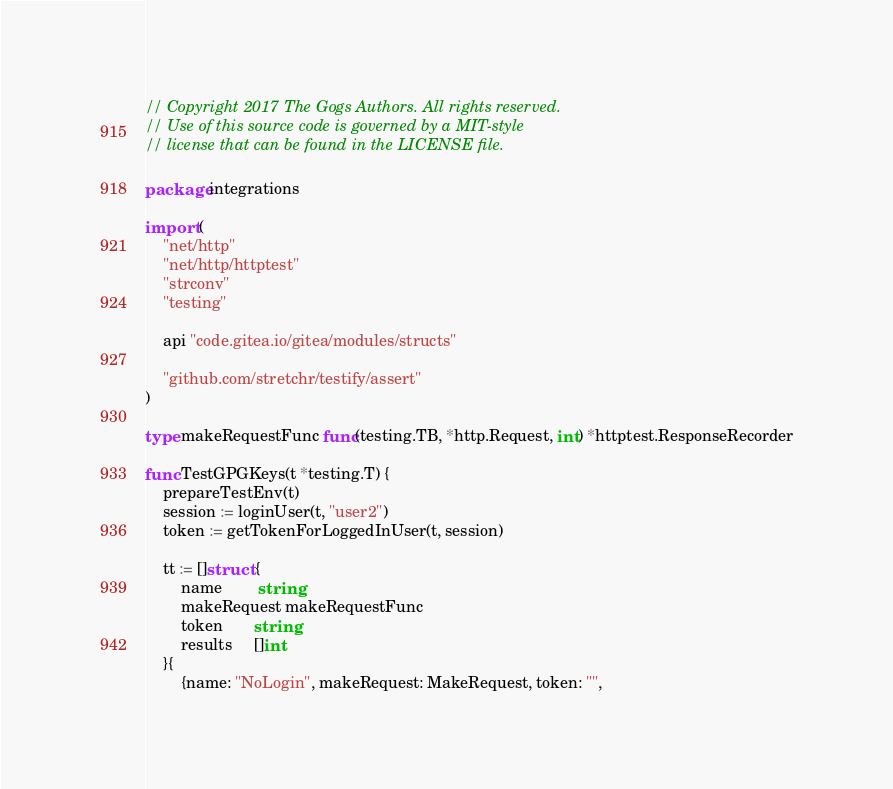<code> <loc_0><loc_0><loc_500><loc_500><_Go_>// Copyright 2017 The Gogs Authors. All rights reserved.
// Use of this source code is governed by a MIT-style
// license that can be found in the LICENSE file.

package integrations

import (
	"net/http"
	"net/http/httptest"
	"strconv"
	"testing"

	api "code.gitea.io/gitea/modules/structs"

	"github.com/stretchr/testify/assert"
)

type makeRequestFunc func(testing.TB, *http.Request, int) *httptest.ResponseRecorder

func TestGPGKeys(t *testing.T) {
	prepareTestEnv(t)
	session := loginUser(t, "user2")
	token := getTokenForLoggedInUser(t, session)

	tt := []struct {
		name        string
		makeRequest makeRequestFunc
		token       string
		results     []int
	}{
		{name: "NoLogin", makeRequest: MakeRequest, token: "",</code> 